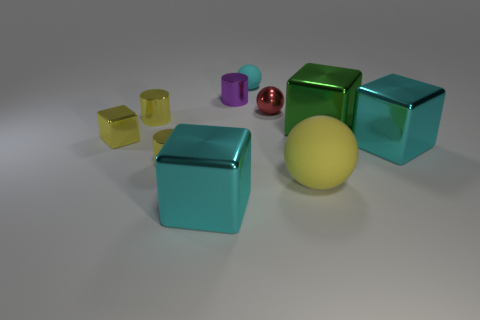There is a large green metallic thing; does it have the same shape as the large cyan metal thing to the left of the small matte sphere?
Offer a very short reply. Yes. There is a cyan thing that is in front of the green block and to the left of the red metallic thing; what is it made of?
Provide a succinct answer. Metal. The metallic block that is the same size as the red shiny thing is what color?
Ensure brevity in your answer.  Yellow. Do the tiny cyan object and the big cyan object that is left of the big yellow rubber sphere have the same material?
Provide a short and direct response. No. What number of other things are the same size as the purple shiny cylinder?
Ensure brevity in your answer.  5. There is a matte object in front of the small metallic cylinder in front of the small yellow shiny block; are there any small yellow metal objects to the right of it?
Make the answer very short. No. What size is the purple thing?
Your answer should be very brief. Small. How big is the matte ball that is to the right of the red shiny sphere?
Provide a short and direct response. Large. Is the size of the cyan shiny cube on the left side of the purple thing the same as the purple shiny cylinder?
Offer a terse response. No. Is there anything else of the same color as the metallic ball?
Ensure brevity in your answer.  No. 